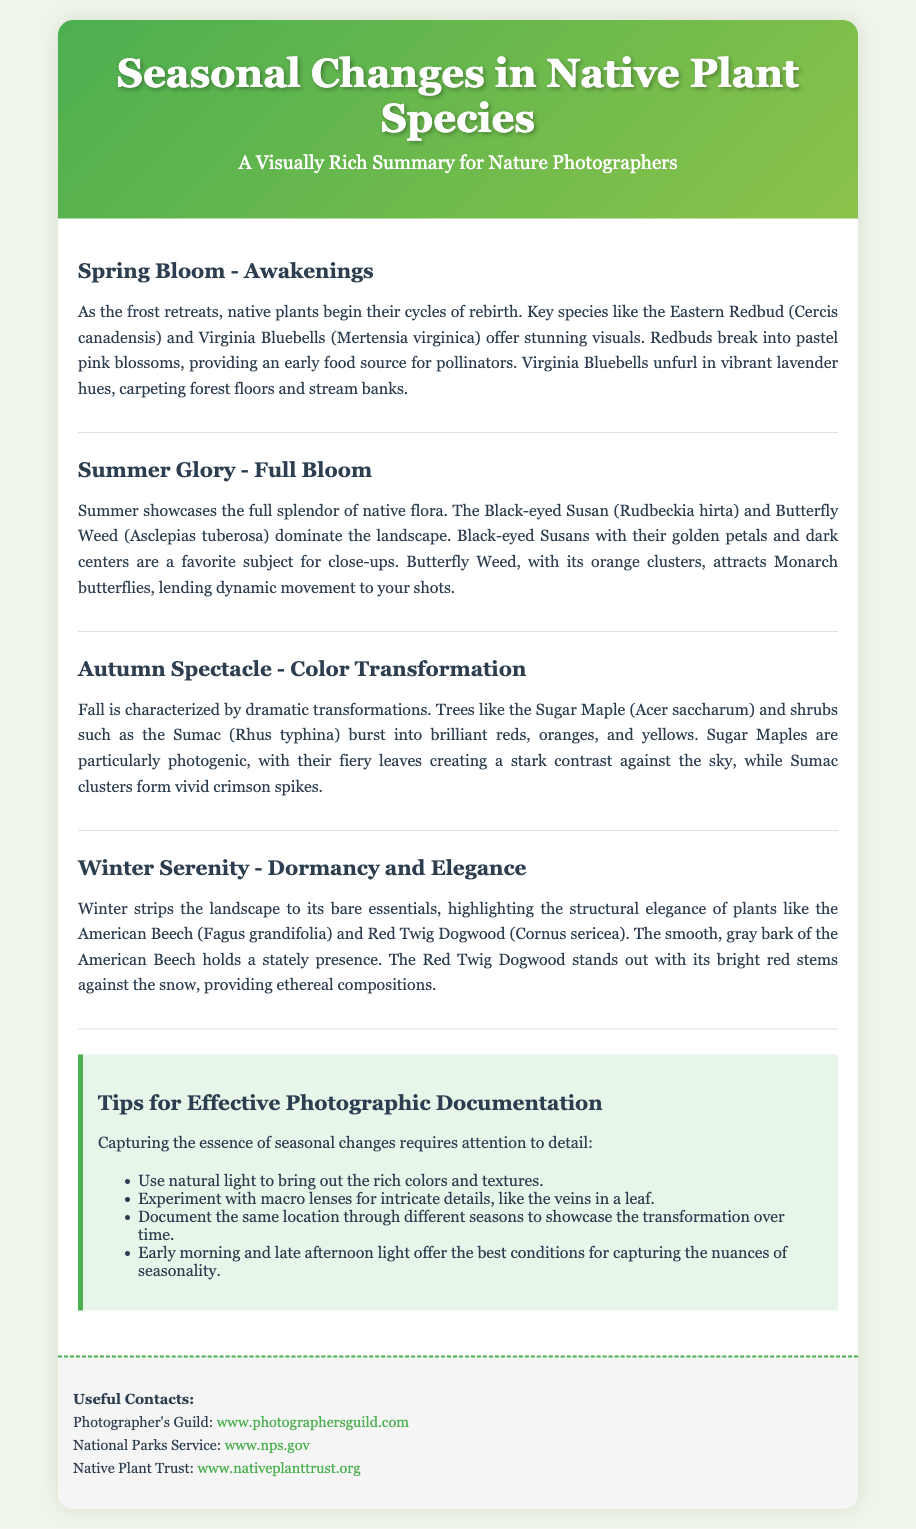What tree is known for its pastel pink blossoms in spring? The document specifies that the Eastern Redbud is known for its pastel pink blossoms in spring, making it a key species during this season.
Answer: Eastern Redbud Which plant attracts Monarch butterflies in the summer? According to the document, Butterfly Weed attracts Monarch butterflies, enhancing summertime photography opportunities.
Answer: Butterfly Weed What color do Sugar Maple leaves turn in autumn? The document describes that Sugar Maple leaves burst into brilliant reds, oranges, and yellows during autumn.
Answer: Brilliant reds, oranges, and yellows What time of day offers the best light for capturing seasonal changes? The document suggests that early morning and late afternoon light provide the best conditions for photography in relation to seasonal changes.
Answer: Early morning and late afternoon Name one shrub mentioned in the winter section of the Playbill. The document lists the Red Twig Dogwood as a notable shrub during the winter season, particularly due to its bright red stems.
Answer: Red Twig Dogwood What visual aspect is highlighted in winter for the American Beech? The document emphasizes the structural elegance of the American Beech, highlighting its smooth, gray bark's stately presence in winter.
Answer: Structural elegance In which section are Virginia Bluebells mentioned? Virginia Bluebells are mentioned in the spring section, specifically as they unfurl in vibrant lavender hues.
Answer: Spring Bloom - Awakenings How many tips are suggested for effective photographic documentation? The document lists four specific tips to enhance the effectiveness of photographic documentation regarding seasonal changes.
Answer: Four 